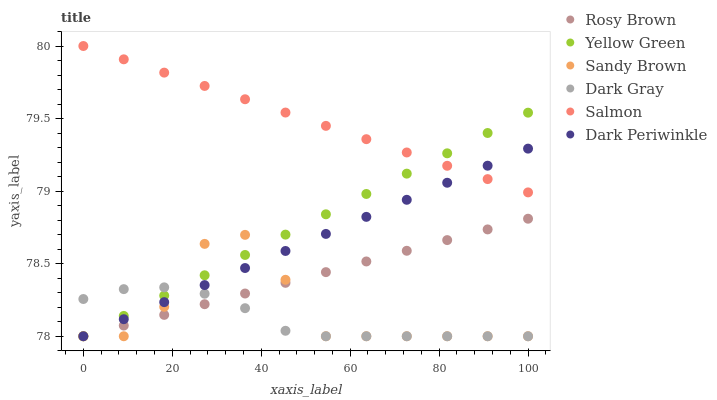Does Dark Gray have the minimum area under the curve?
Answer yes or no. Yes. Does Salmon have the maximum area under the curve?
Answer yes or no. Yes. Does Rosy Brown have the minimum area under the curve?
Answer yes or no. No. Does Rosy Brown have the maximum area under the curve?
Answer yes or no. No. Is Rosy Brown the smoothest?
Answer yes or no. Yes. Is Sandy Brown the roughest?
Answer yes or no. Yes. Is Salmon the smoothest?
Answer yes or no. No. Is Salmon the roughest?
Answer yes or no. No. Does Yellow Green have the lowest value?
Answer yes or no. Yes. Does Salmon have the lowest value?
Answer yes or no. No. Does Salmon have the highest value?
Answer yes or no. Yes. Does Rosy Brown have the highest value?
Answer yes or no. No. Is Rosy Brown less than Salmon?
Answer yes or no. Yes. Is Salmon greater than Dark Gray?
Answer yes or no. Yes. Does Salmon intersect Dark Periwinkle?
Answer yes or no. Yes. Is Salmon less than Dark Periwinkle?
Answer yes or no. No. Is Salmon greater than Dark Periwinkle?
Answer yes or no. No. Does Rosy Brown intersect Salmon?
Answer yes or no. No. 